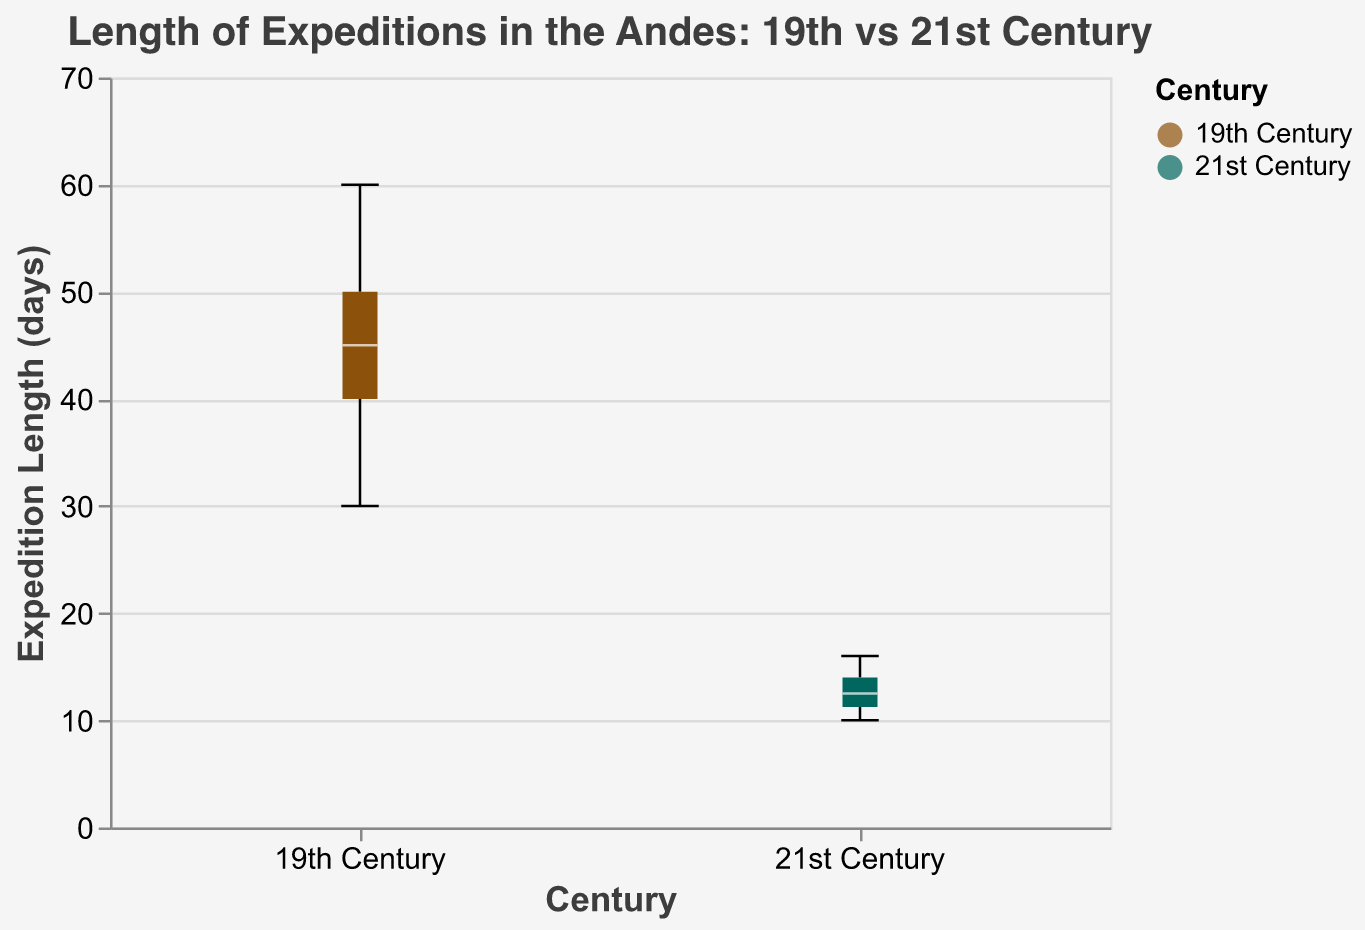What's the title of the figure? The title is typically found at the top of the chart. In this case, it reads "Length of Expeditions in the Andes: 19th vs 21st Century" as specified in the code.
Answer: Length of Expeditions in the Andes: 19th vs 21st Century What are the groups being compared in the box plot? The groups can be identified by looking at the x-axis labels and color legend. According to the chart, there are two groups: "19th Century" and "21st Century".
Answer: 19th Century, 21st Century Which group has a higher median length of expeditions? The median is represented by a tick in the box plot and usually shown as a line inside each box. In this case, the 19th Century group has a higher median value than the 21st Century group.
Answer: 19th Century What is the maximum length of expeditions in the 21st Century group? This can be found by looking at the top edge of the whisker for the 21st Century group. The maximum value indicated is 16 days.
Answer: 16 days What is the range of expedition lengths in the 19th Century group? The range is the difference between the maximum and minimum values in the box plot. For the 19th Century group, the maximum is 60 days and the minimum is 30 days, so the range is 60 - 30 = 30 days.
Answer: 30 days What's the difference in the median length of expeditions between the 19th Century and the 21st Century groups? To find this, compare the median lines of both groups. If the 19th Century's median is 45 days and the 21st Century's is 13 days, the difference is 45 - 13 = 32 days.
Answer: 32 days Which group has a larger interquartile range (IQR) for expedition lengths? The IQR is the length of the box (the distance between the first quartile and the third quartile). This can be visually estimated: the box for the 19th Century group is wider than that of the 21st Century group.
Answer: 19th Century How does the minimum length of expeditions compare between the 19th and 21st Century groups? The minimum value is found at the bottom of the whisker. For the 19th Century group, it is 30 days, and for the 21st Century group, it is 10 days, so the 19th Century group has a higher minimum length.
Answer: 19th Century What is the most common (median) length of expeditions in the 21st Century group? The median value in the box plot represents the most common/central values. For the 21st Century group, this value is 13 days.
Answer: 13 days 